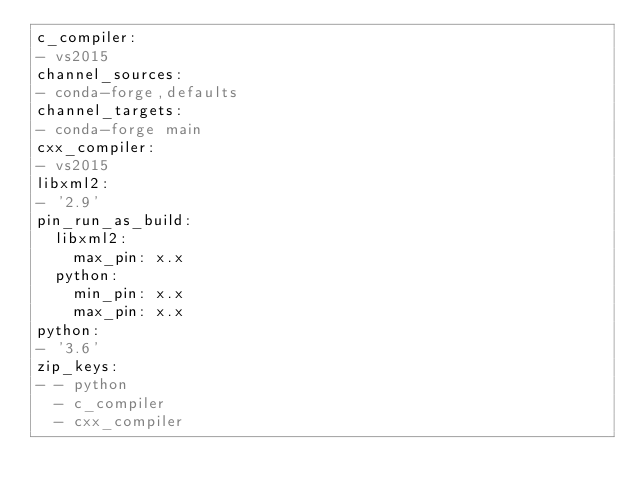Convert code to text. <code><loc_0><loc_0><loc_500><loc_500><_YAML_>c_compiler:
- vs2015
channel_sources:
- conda-forge,defaults
channel_targets:
- conda-forge main
cxx_compiler:
- vs2015
libxml2:
- '2.9'
pin_run_as_build:
  libxml2:
    max_pin: x.x
  python:
    min_pin: x.x
    max_pin: x.x
python:
- '3.6'
zip_keys:
- - python
  - c_compiler
  - cxx_compiler
</code> 